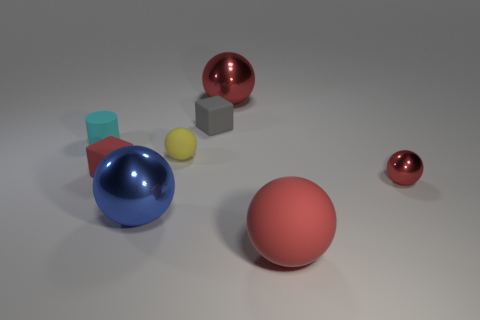What is the material of the large thing that is to the right of the blue thing and in front of the tiny red rubber block?
Your answer should be very brief. Rubber. How many yellow rubber things have the same size as the red cube?
Provide a succinct answer. 1. There is a tiny red object that is the same shape as the tiny gray matte object; what material is it?
Your answer should be very brief. Rubber. How many objects are tiny red shiny things that are right of the gray object or red metal things behind the yellow sphere?
Make the answer very short. 2. There is a tiny red matte object; is it the same shape as the rubber object behind the small cyan matte thing?
Give a very brief answer. Yes. What is the shape of the red thing in front of the metallic thing right of the red metallic ball that is behind the gray matte thing?
Offer a terse response. Sphere. What number of other things are there of the same material as the tiny yellow ball
Your response must be concise. 4. What number of things are red things to the left of the large red rubber ball or big brown balls?
Provide a succinct answer. 2. The big red thing that is in front of the red thing that is on the right side of the large rubber object is what shape?
Give a very brief answer. Sphere. Does the big metal object that is behind the yellow sphere have the same shape as the small yellow rubber object?
Offer a terse response. Yes. 